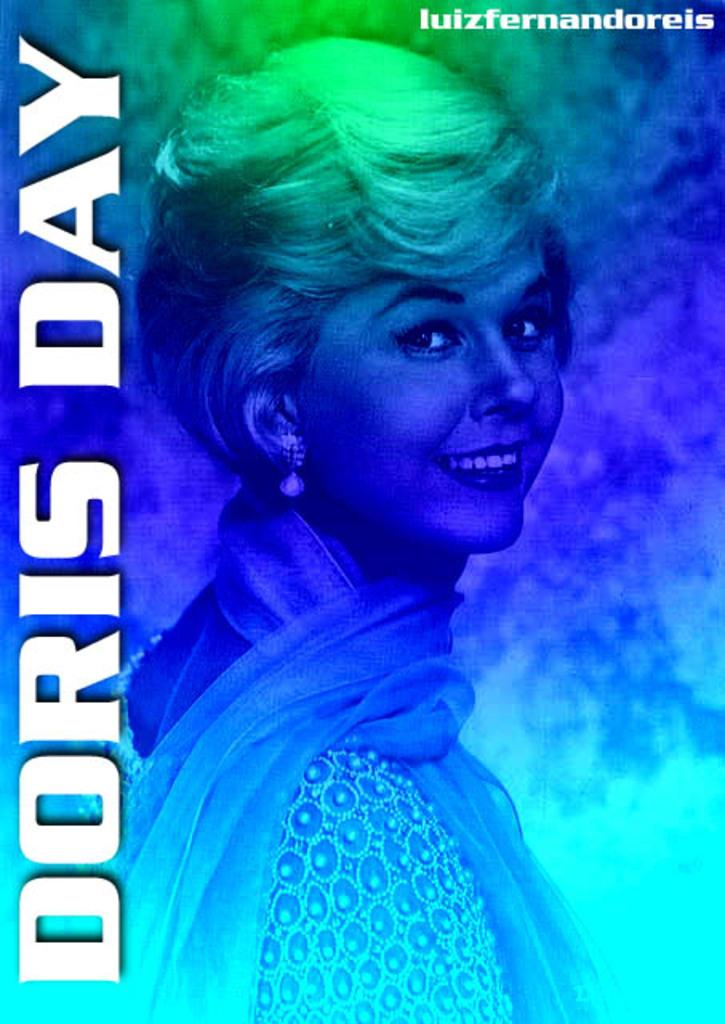What is featured on the poster in the image? The poster in the image contains text and an image of a person. Can you describe the image of the person on the poster? Unfortunately, the specific details of the person's image on the poster cannot be determined from the provided facts. What is the purpose of the text on the poster? The purpose of the text on the poster cannot be determined from the provided facts. What type of chalk is being used by the person in the image? There is no chalk present in the image, and therefore no such activity can be observed. 